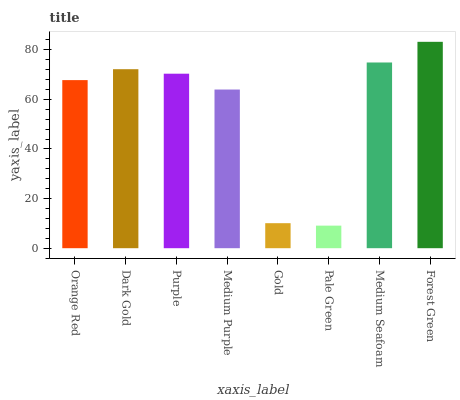Is Pale Green the minimum?
Answer yes or no. Yes. Is Forest Green the maximum?
Answer yes or no. Yes. Is Dark Gold the minimum?
Answer yes or no. No. Is Dark Gold the maximum?
Answer yes or no. No. Is Dark Gold greater than Orange Red?
Answer yes or no. Yes. Is Orange Red less than Dark Gold?
Answer yes or no. Yes. Is Orange Red greater than Dark Gold?
Answer yes or no. No. Is Dark Gold less than Orange Red?
Answer yes or no. No. Is Purple the high median?
Answer yes or no. Yes. Is Orange Red the low median?
Answer yes or no. Yes. Is Gold the high median?
Answer yes or no. No. Is Medium Purple the low median?
Answer yes or no. No. 